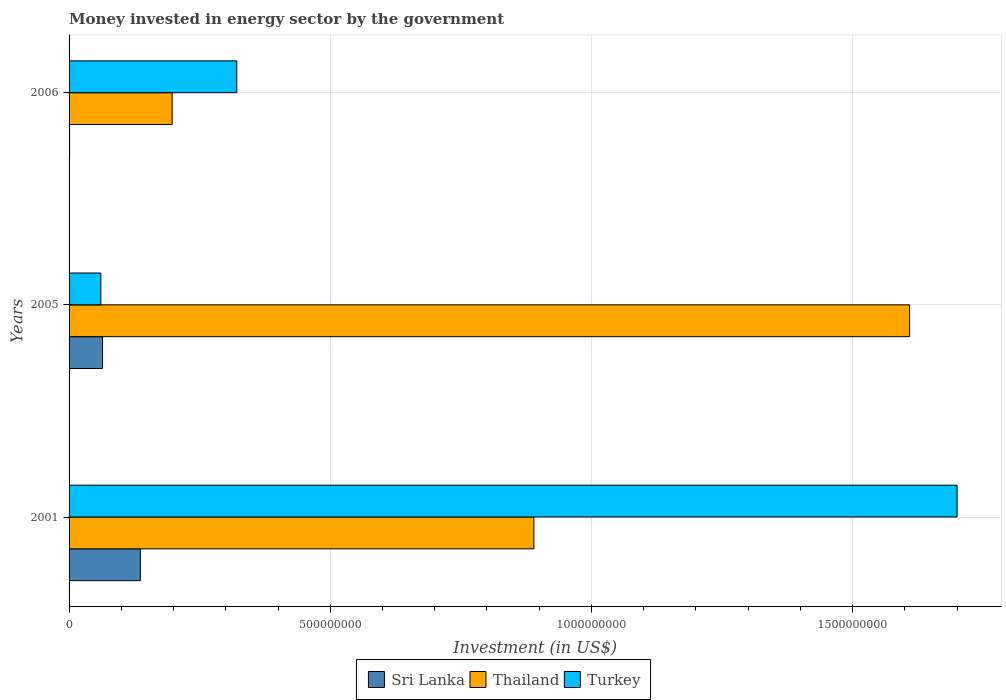How many groups of bars are there?
Provide a short and direct response. 3. Are the number of bars per tick equal to the number of legend labels?
Make the answer very short. Yes. Are the number of bars on each tick of the Y-axis equal?
Give a very brief answer. Yes. How many bars are there on the 1st tick from the top?
Provide a short and direct response. 3. What is the money spent in energy sector in Thailand in 2005?
Your response must be concise. 1.61e+09. Across all years, what is the maximum money spent in energy sector in Turkey?
Make the answer very short. 1.70e+09. Across all years, what is the minimum money spent in energy sector in Turkey?
Your response must be concise. 6.08e+07. In which year was the money spent in energy sector in Thailand maximum?
Make the answer very short. 2005. What is the total money spent in energy sector in Thailand in the graph?
Make the answer very short. 2.70e+09. What is the difference between the money spent in energy sector in Sri Lanka in 2001 and that in 2005?
Make the answer very short. 7.24e+07. What is the difference between the money spent in energy sector in Thailand in 2006 and the money spent in energy sector in Turkey in 2001?
Keep it short and to the point. -1.50e+09. What is the average money spent in energy sector in Thailand per year?
Your answer should be very brief. 8.99e+08. In the year 2005, what is the difference between the money spent in energy sector in Turkey and money spent in energy sector in Thailand?
Provide a succinct answer. -1.55e+09. In how many years, is the money spent in energy sector in Sri Lanka greater than 1100000000 US$?
Provide a short and direct response. 0. What is the ratio of the money spent in energy sector in Turkey in 2001 to that in 2006?
Ensure brevity in your answer.  5.3. Is the difference between the money spent in energy sector in Turkey in 2001 and 2005 greater than the difference between the money spent in energy sector in Thailand in 2001 and 2005?
Provide a succinct answer. Yes. What is the difference between the highest and the second highest money spent in energy sector in Sri Lanka?
Your response must be concise. 7.24e+07. What is the difference between the highest and the lowest money spent in energy sector in Turkey?
Your answer should be very brief. 1.64e+09. In how many years, is the money spent in energy sector in Sri Lanka greater than the average money spent in energy sector in Sri Lanka taken over all years?
Offer a terse response. 1. Is the sum of the money spent in energy sector in Thailand in 2001 and 2005 greater than the maximum money spent in energy sector in Turkey across all years?
Offer a very short reply. Yes. What does the 2nd bar from the top in 2005 represents?
Ensure brevity in your answer.  Thailand. What does the 3rd bar from the bottom in 2006 represents?
Your answer should be compact. Turkey. How many years are there in the graph?
Offer a very short reply. 3. What is the difference between two consecutive major ticks on the X-axis?
Offer a terse response. 5.00e+08. Where does the legend appear in the graph?
Keep it short and to the point. Bottom center. What is the title of the graph?
Offer a terse response. Money invested in energy sector by the government. What is the label or title of the X-axis?
Provide a succinct answer. Investment (in US$). What is the label or title of the Y-axis?
Give a very brief answer. Years. What is the Investment (in US$) of Sri Lanka in 2001?
Make the answer very short. 1.36e+08. What is the Investment (in US$) of Thailand in 2001?
Offer a terse response. 8.90e+08. What is the Investment (in US$) of Turkey in 2001?
Provide a short and direct response. 1.70e+09. What is the Investment (in US$) in Sri Lanka in 2005?
Give a very brief answer. 6.41e+07. What is the Investment (in US$) of Thailand in 2005?
Your answer should be compact. 1.61e+09. What is the Investment (in US$) of Turkey in 2005?
Provide a short and direct response. 6.08e+07. What is the Investment (in US$) of Sri Lanka in 2006?
Provide a short and direct response. 1.00e+06. What is the Investment (in US$) in Thailand in 2006?
Offer a terse response. 1.97e+08. What is the Investment (in US$) of Turkey in 2006?
Keep it short and to the point. 3.21e+08. Across all years, what is the maximum Investment (in US$) of Sri Lanka?
Ensure brevity in your answer.  1.36e+08. Across all years, what is the maximum Investment (in US$) in Thailand?
Your response must be concise. 1.61e+09. Across all years, what is the maximum Investment (in US$) in Turkey?
Your answer should be compact. 1.70e+09. Across all years, what is the minimum Investment (in US$) of Sri Lanka?
Provide a succinct answer. 1.00e+06. Across all years, what is the minimum Investment (in US$) of Thailand?
Keep it short and to the point. 1.97e+08. Across all years, what is the minimum Investment (in US$) in Turkey?
Ensure brevity in your answer.  6.08e+07. What is the total Investment (in US$) in Sri Lanka in the graph?
Offer a terse response. 2.02e+08. What is the total Investment (in US$) in Thailand in the graph?
Make the answer very short. 2.70e+09. What is the total Investment (in US$) of Turkey in the graph?
Your answer should be compact. 2.08e+09. What is the difference between the Investment (in US$) of Sri Lanka in 2001 and that in 2005?
Your response must be concise. 7.24e+07. What is the difference between the Investment (in US$) of Thailand in 2001 and that in 2005?
Provide a short and direct response. -7.19e+08. What is the difference between the Investment (in US$) of Turkey in 2001 and that in 2005?
Make the answer very short. 1.64e+09. What is the difference between the Investment (in US$) of Sri Lanka in 2001 and that in 2006?
Your answer should be compact. 1.36e+08. What is the difference between the Investment (in US$) of Thailand in 2001 and that in 2006?
Ensure brevity in your answer.  6.92e+08. What is the difference between the Investment (in US$) in Turkey in 2001 and that in 2006?
Ensure brevity in your answer.  1.38e+09. What is the difference between the Investment (in US$) of Sri Lanka in 2005 and that in 2006?
Ensure brevity in your answer.  6.31e+07. What is the difference between the Investment (in US$) of Thailand in 2005 and that in 2006?
Make the answer very short. 1.41e+09. What is the difference between the Investment (in US$) in Turkey in 2005 and that in 2006?
Give a very brief answer. -2.60e+08. What is the difference between the Investment (in US$) of Sri Lanka in 2001 and the Investment (in US$) of Thailand in 2005?
Give a very brief answer. -1.47e+09. What is the difference between the Investment (in US$) of Sri Lanka in 2001 and the Investment (in US$) of Turkey in 2005?
Ensure brevity in your answer.  7.57e+07. What is the difference between the Investment (in US$) in Thailand in 2001 and the Investment (in US$) in Turkey in 2005?
Your answer should be compact. 8.29e+08. What is the difference between the Investment (in US$) in Sri Lanka in 2001 and the Investment (in US$) in Thailand in 2006?
Give a very brief answer. -6.08e+07. What is the difference between the Investment (in US$) in Sri Lanka in 2001 and the Investment (in US$) in Turkey in 2006?
Provide a short and direct response. -1.85e+08. What is the difference between the Investment (in US$) of Thailand in 2001 and the Investment (in US$) of Turkey in 2006?
Provide a short and direct response. 5.69e+08. What is the difference between the Investment (in US$) of Sri Lanka in 2005 and the Investment (in US$) of Thailand in 2006?
Your answer should be very brief. -1.33e+08. What is the difference between the Investment (in US$) in Sri Lanka in 2005 and the Investment (in US$) in Turkey in 2006?
Ensure brevity in your answer.  -2.57e+08. What is the difference between the Investment (in US$) in Thailand in 2005 and the Investment (in US$) in Turkey in 2006?
Offer a terse response. 1.29e+09. What is the average Investment (in US$) in Sri Lanka per year?
Your response must be concise. 6.72e+07. What is the average Investment (in US$) of Thailand per year?
Make the answer very short. 8.99e+08. What is the average Investment (in US$) of Turkey per year?
Provide a short and direct response. 6.94e+08. In the year 2001, what is the difference between the Investment (in US$) of Sri Lanka and Investment (in US$) of Thailand?
Your answer should be very brief. -7.53e+08. In the year 2001, what is the difference between the Investment (in US$) of Sri Lanka and Investment (in US$) of Turkey?
Your response must be concise. -1.56e+09. In the year 2001, what is the difference between the Investment (in US$) in Thailand and Investment (in US$) in Turkey?
Your response must be concise. -8.10e+08. In the year 2005, what is the difference between the Investment (in US$) of Sri Lanka and Investment (in US$) of Thailand?
Provide a succinct answer. -1.54e+09. In the year 2005, what is the difference between the Investment (in US$) in Sri Lanka and Investment (in US$) in Turkey?
Ensure brevity in your answer.  3.30e+06. In the year 2005, what is the difference between the Investment (in US$) in Thailand and Investment (in US$) in Turkey?
Give a very brief answer. 1.55e+09. In the year 2006, what is the difference between the Investment (in US$) in Sri Lanka and Investment (in US$) in Thailand?
Keep it short and to the point. -1.96e+08. In the year 2006, what is the difference between the Investment (in US$) of Sri Lanka and Investment (in US$) of Turkey?
Offer a terse response. -3.20e+08. In the year 2006, what is the difference between the Investment (in US$) of Thailand and Investment (in US$) of Turkey?
Provide a succinct answer. -1.24e+08. What is the ratio of the Investment (in US$) of Sri Lanka in 2001 to that in 2005?
Keep it short and to the point. 2.13. What is the ratio of the Investment (in US$) in Thailand in 2001 to that in 2005?
Provide a succinct answer. 0.55. What is the ratio of the Investment (in US$) in Turkey in 2001 to that in 2005?
Keep it short and to the point. 27.96. What is the ratio of the Investment (in US$) of Sri Lanka in 2001 to that in 2006?
Give a very brief answer. 136.5. What is the ratio of the Investment (in US$) of Thailand in 2001 to that in 2006?
Offer a terse response. 4.51. What is the ratio of the Investment (in US$) of Turkey in 2001 to that in 2006?
Keep it short and to the point. 5.3. What is the ratio of the Investment (in US$) of Sri Lanka in 2005 to that in 2006?
Your answer should be compact. 64.1. What is the ratio of the Investment (in US$) in Thailand in 2005 to that in 2006?
Ensure brevity in your answer.  8.16. What is the ratio of the Investment (in US$) of Turkey in 2005 to that in 2006?
Your answer should be very brief. 0.19. What is the difference between the highest and the second highest Investment (in US$) in Sri Lanka?
Make the answer very short. 7.24e+07. What is the difference between the highest and the second highest Investment (in US$) of Thailand?
Provide a succinct answer. 7.19e+08. What is the difference between the highest and the second highest Investment (in US$) of Turkey?
Provide a succinct answer. 1.38e+09. What is the difference between the highest and the lowest Investment (in US$) in Sri Lanka?
Your answer should be compact. 1.36e+08. What is the difference between the highest and the lowest Investment (in US$) in Thailand?
Your answer should be compact. 1.41e+09. What is the difference between the highest and the lowest Investment (in US$) of Turkey?
Ensure brevity in your answer.  1.64e+09. 